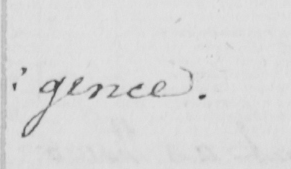Can you tell me what this handwritten text says? : gence . 